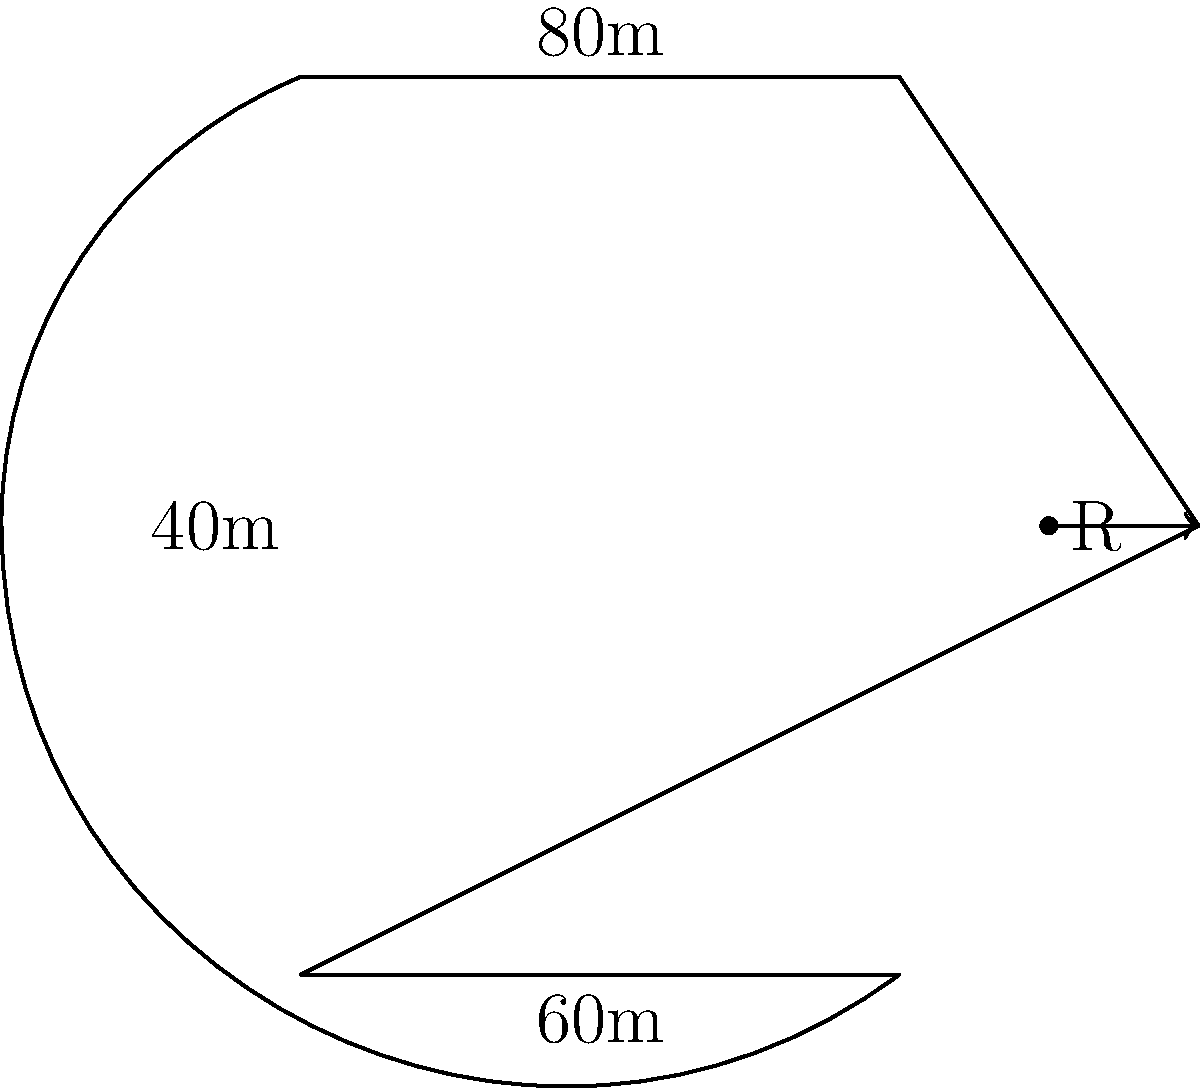As a sponsored athlete, you're designing a new running track for your community. The track has straight sides of 80m and curved ends that form perfect semicircles. If the width of the track is 40m, what is the total area of the running track in square meters? (Use $\pi \approx 3.14$) Let's approach this step-by-step:

1) The track consists of a rectangle in the middle and two semicircles at the ends.

2) Area of the rectangle:
   Length = 80m, Width = 40m
   $A_{rectangle} = 80 \times 40 = 3200$ m²

3) For the semicircles:
   The radius (R) is half the width of the track: $R = 40 \div 2 = 20$ m

4) Area of a full circle with this radius:
   $A_{circle} = \pi R^2 = 3.14 \times 20^2 = 1256$ m²

5) We need two semicircles, which is equivalent to one full circle:
   $A_{semicircles} = 1256$ m²

6) Total area:
   $A_{total} = A_{rectangle} + A_{semicircles}$
   $A_{total} = 3200 + 1256 = 4456$ m²

Therefore, the total area of the running track is 4456 square meters.
Answer: 4456 m² 